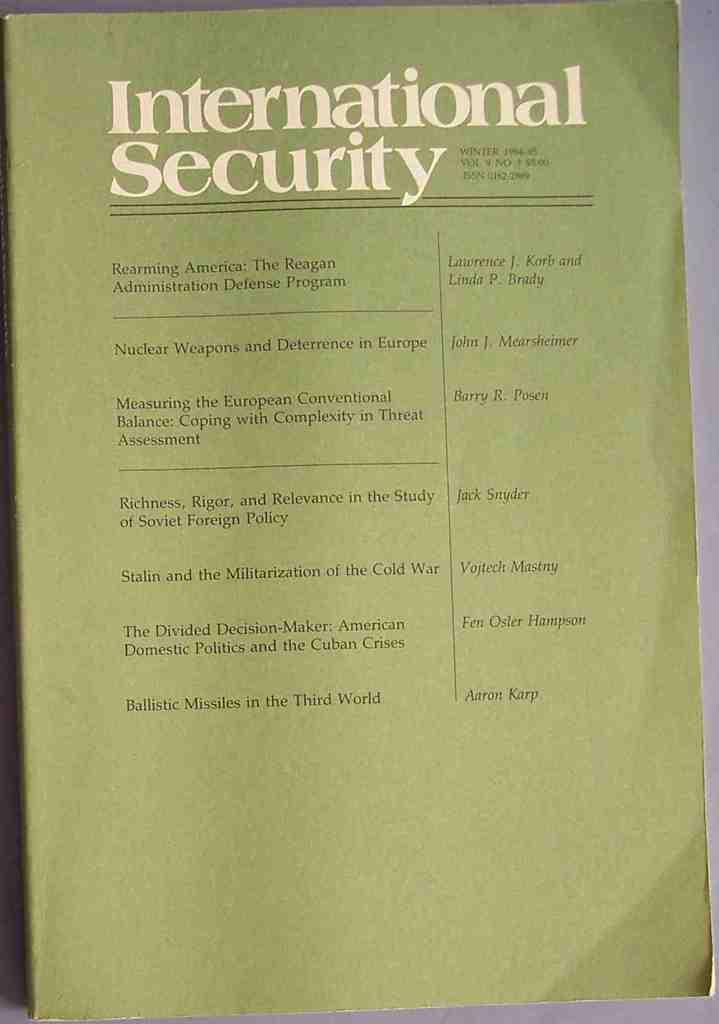<image>
Give a short and clear explanation of the subsequent image. a page that says 'international security' at the top of it 